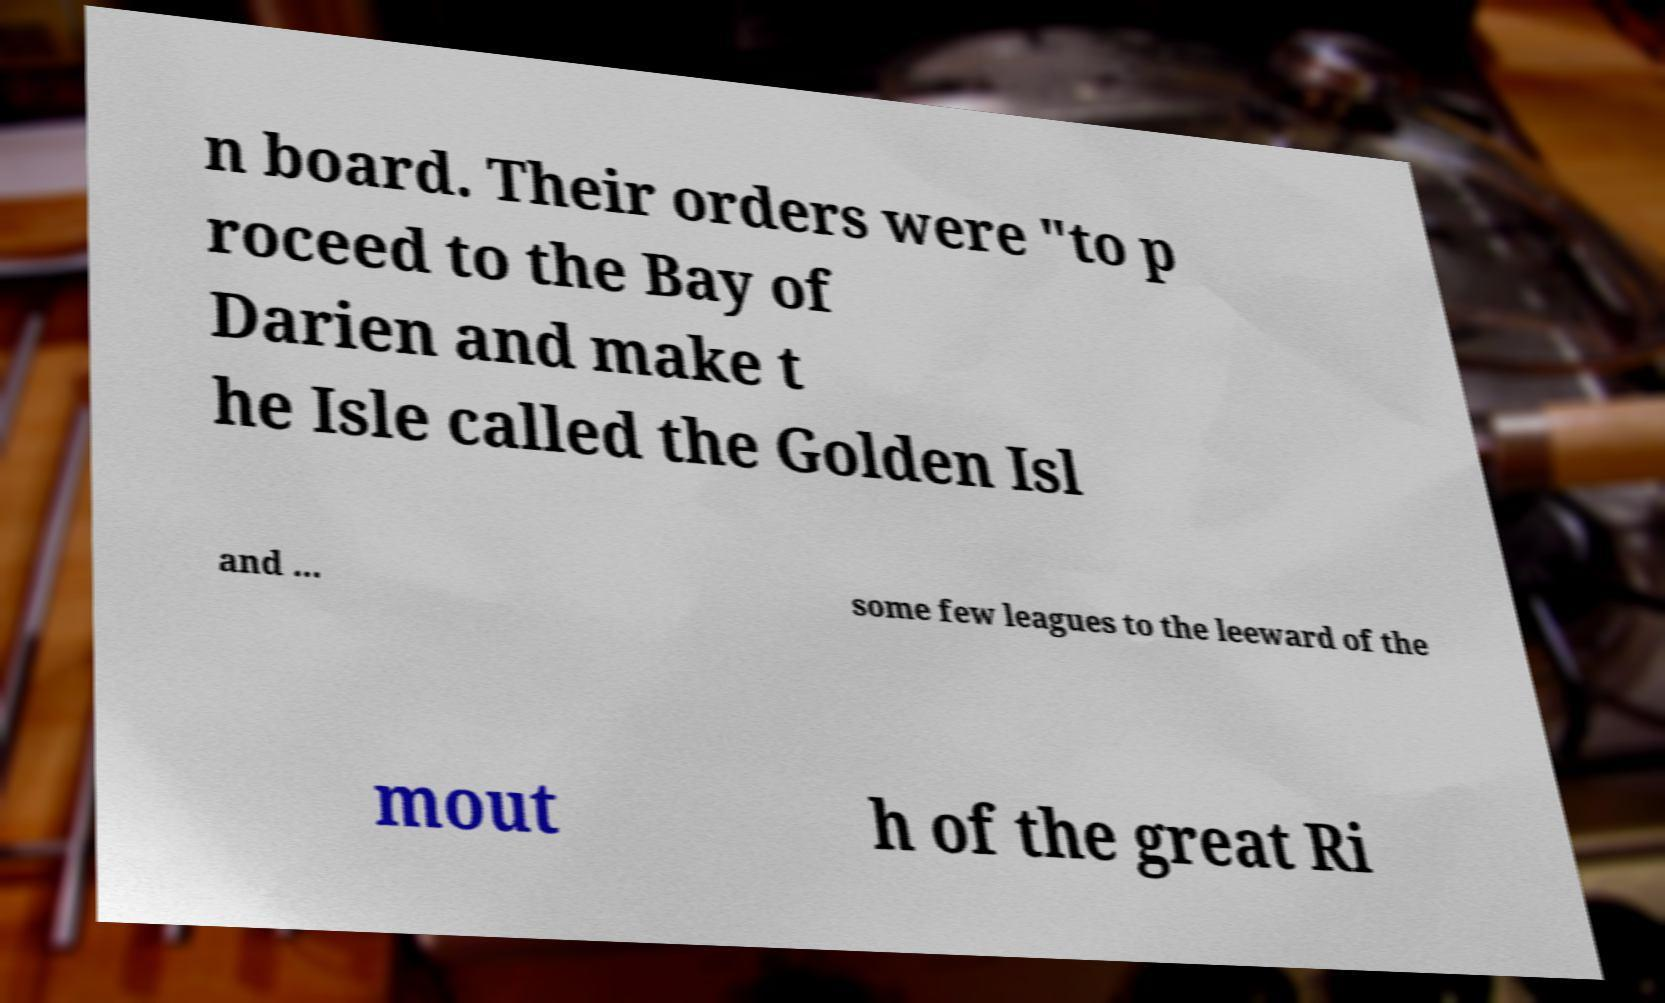Can you read and provide the text displayed in the image?This photo seems to have some interesting text. Can you extract and type it out for me? n board. Their orders were "to p roceed to the Bay of Darien and make t he Isle called the Golden Isl and ... some few leagues to the leeward of the mout h of the great Ri 